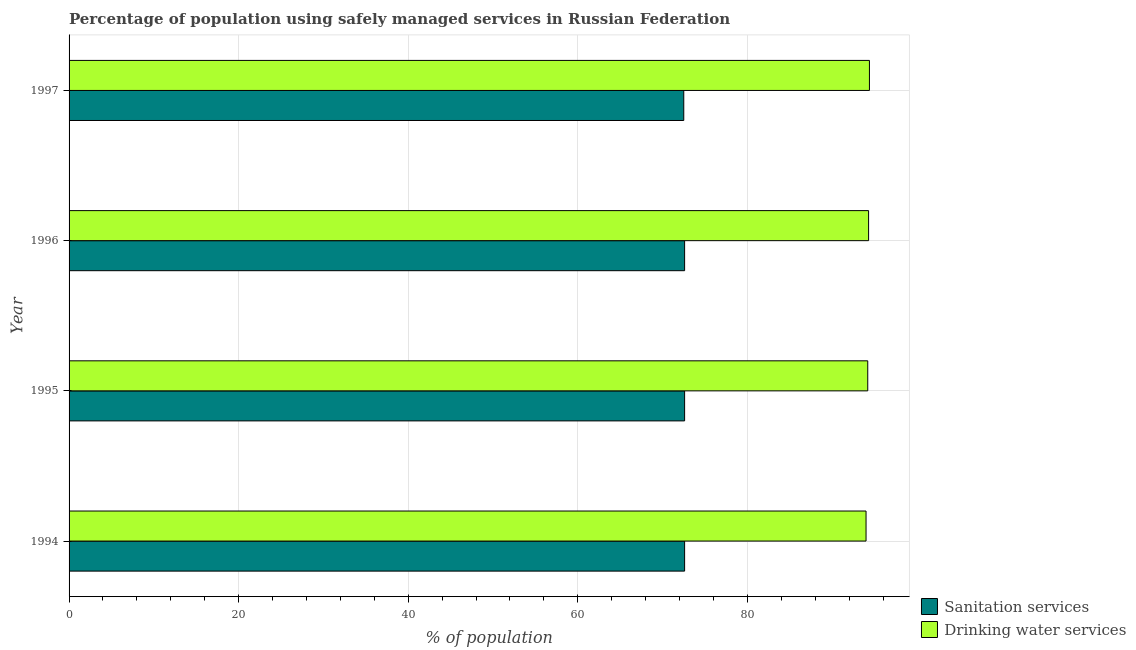How many different coloured bars are there?
Give a very brief answer. 2. How many groups of bars are there?
Your response must be concise. 4. Are the number of bars per tick equal to the number of legend labels?
Provide a short and direct response. Yes. How many bars are there on the 3rd tick from the top?
Your answer should be very brief. 2. What is the percentage of population who used drinking water services in 1995?
Make the answer very short. 94.2. Across all years, what is the maximum percentage of population who used drinking water services?
Your answer should be compact. 94.4. Across all years, what is the minimum percentage of population who used sanitation services?
Your answer should be compact. 72.5. In which year was the percentage of population who used drinking water services maximum?
Your answer should be compact. 1997. What is the total percentage of population who used sanitation services in the graph?
Your answer should be compact. 290.3. What is the difference between the percentage of population who used sanitation services in 1997 and the percentage of population who used drinking water services in 1994?
Your answer should be very brief. -21.5. What is the average percentage of population who used sanitation services per year?
Your answer should be compact. 72.58. In the year 1997, what is the difference between the percentage of population who used sanitation services and percentage of population who used drinking water services?
Your answer should be compact. -21.9. In how many years, is the percentage of population who used drinking water services greater than 56 %?
Your response must be concise. 4. Is the percentage of population who used drinking water services in 1995 less than that in 1997?
Offer a terse response. Yes. Is the difference between the percentage of population who used drinking water services in 1995 and 1997 greater than the difference between the percentage of population who used sanitation services in 1995 and 1997?
Offer a very short reply. No. What is the difference between the highest and the lowest percentage of population who used sanitation services?
Give a very brief answer. 0.1. What does the 1st bar from the top in 1995 represents?
Make the answer very short. Drinking water services. What does the 2nd bar from the bottom in 1997 represents?
Ensure brevity in your answer.  Drinking water services. How many bars are there?
Your response must be concise. 8. Are all the bars in the graph horizontal?
Make the answer very short. Yes. How many years are there in the graph?
Offer a terse response. 4. What is the difference between two consecutive major ticks on the X-axis?
Your response must be concise. 20. Does the graph contain any zero values?
Keep it short and to the point. No. What is the title of the graph?
Keep it short and to the point. Percentage of population using safely managed services in Russian Federation. What is the label or title of the X-axis?
Make the answer very short. % of population. What is the % of population of Sanitation services in 1994?
Offer a very short reply. 72.6. What is the % of population of Drinking water services in 1994?
Provide a short and direct response. 94. What is the % of population in Sanitation services in 1995?
Your answer should be compact. 72.6. What is the % of population of Drinking water services in 1995?
Provide a short and direct response. 94.2. What is the % of population in Sanitation services in 1996?
Offer a terse response. 72.6. What is the % of population of Drinking water services in 1996?
Provide a short and direct response. 94.3. What is the % of population of Sanitation services in 1997?
Ensure brevity in your answer.  72.5. What is the % of population of Drinking water services in 1997?
Your response must be concise. 94.4. Across all years, what is the maximum % of population of Sanitation services?
Provide a succinct answer. 72.6. Across all years, what is the maximum % of population of Drinking water services?
Offer a very short reply. 94.4. Across all years, what is the minimum % of population in Sanitation services?
Keep it short and to the point. 72.5. Across all years, what is the minimum % of population in Drinking water services?
Offer a terse response. 94. What is the total % of population of Sanitation services in the graph?
Make the answer very short. 290.3. What is the total % of population of Drinking water services in the graph?
Your answer should be compact. 376.9. What is the difference between the % of population in Sanitation services in 1994 and that in 1995?
Keep it short and to the point. 0. What is the difference between the % of population of Drinking water services in 1994 and that in 1995?
Offer a terse response. -0.2. What is the difference between the % of population in Drinking water services in 1994 and that in 1996?
Offer a very short reply. -0.3. What is the difference between the % of population in Sanitation services in 1995 and that in 1996?
Provide a succinct answer. 0. What is the difference between the % of population of Sanitation services in 1995 and that in 1997?
Provide a succinct answer. 0.1. What is the difference between the % of population of Drinking water services in 1995 and that in 1997?
Give a very brief answer. -0.2. What is the difference between the % of population of Sanitation services in 1996 and that in 1997?
Give a very brief answer. 0.1. What is the difference between the % of population of Sanitation services in 1994 and the % of population of Drinking water services in 1995?
Your answer should be very brief. -21.6. What is the difference between the % of population of Sanitation services in 1994 and the % of population of Drinking water services in 1996?
Offer a very short reply. -21.7. What is the difference between the % of population of Sanitation services in 1994 and the % of population of Drinking water services in 1997?
Provide a short and direct response. -21.8. What is the difference between the % of population of Sanitation services in 1995 and the % of population of Drinking water services in 1996?
Your answer should be very brief. -21.7. What is the difference between the % of population of Sanitation services in 1995 and the % of population of Drinking water services in 1997?
Your answer should be very brief. -21.8. What is the difference between the % of population of Sanitation services in 1996 and the % of population of Drinking water services in 1997?
Provide a succinct answer. -21.8. What is the average % of population of Sanitation services per year?
Your answer should be very brief. 72.58. What is the average % of population in Drinking water services per year?
Your answer should be very brief. 94.22. In the year 1994, what is the difference between the % of population of Sanitation services and % of population of Drinking water services?
Give a very brief answer. -21.4. In the year 1995, what is the difference between the % of population in Sanitation services and % of population in Drinking water services?
Make the answer very short. -21.6. In the year 1996, what is the difference between the % of population of Sanitation services and % of population of Drinking water services?
Give a very brief answer. -21.7. In the year 1997, what is the difference between the % of population of Sanitation services and % of population of Drinking water services?
Give a very brief answer. -21.9. What is the ratio of the % of population in Drinking water services in 1994 to that in 1996?
Make the answer very short. 1. What is the ratio of the % of population in Sanitation services in 1995 to that in 1996?
Offer a very short reply. 1. What is the ratio of the % of population in Drinking water services in 1995 to that in 1997?
Provide a short and direct response. 1. What is the difference between the highest and the second highest % of population in Drinking water services?
Offer a terse response. 0.1. What is the difference between the highest and the lowest % of population in Sanitation services?
Provide a short and direct response. 0.1. What is the difference between the highest and the lowest % of population of Drinking water services?
Your answer should be compact. 0.4. 